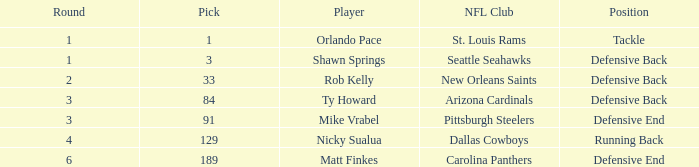What round has a pick less than 189, with arizona cardinals as the NFL club? 3.0. 